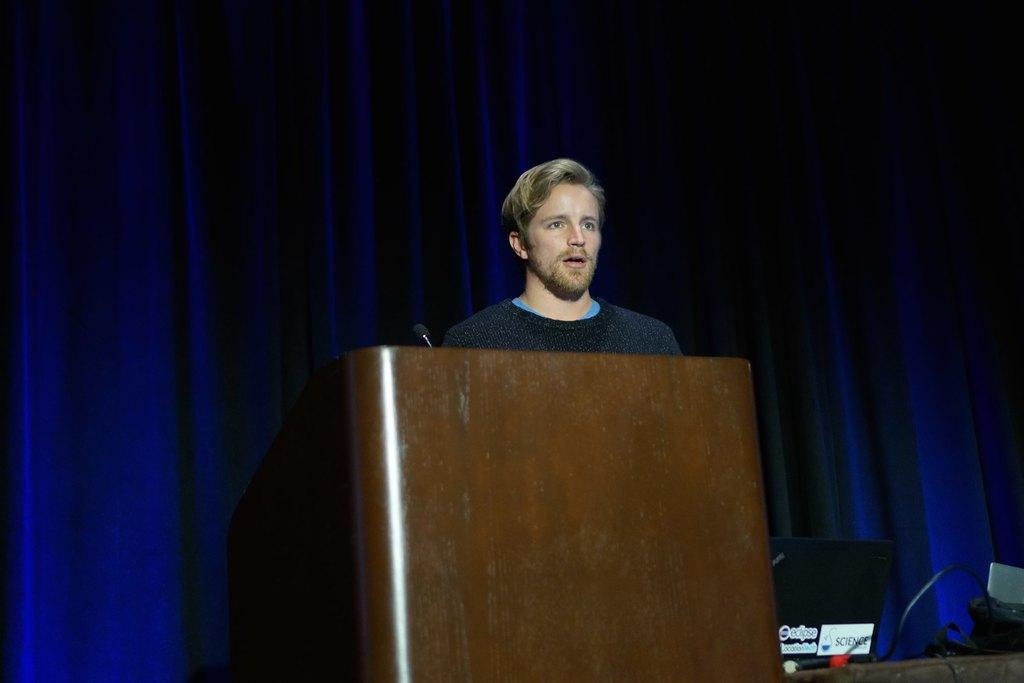What is the man in the image doing? The man is standing in front of a table. What object is near the man? A laptop is present beside the man. Can you describe any other visible elements in the image? There is a wire visible in the image, and there are other unspecified things on the table. What can be seen in the background of the image? There is a curtain in the background of the image. What is the weight of the collar on the railway in the image? There is no railway or collar present in the image. 